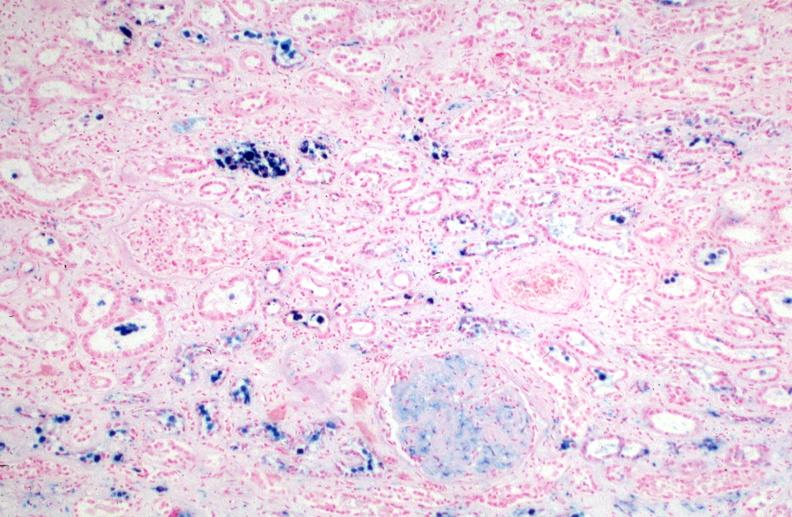does lymphangiomatosis show kidney, chronic sickle cell disease?
Answer the question using a single word or phrase. No 